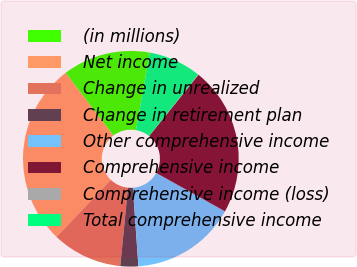Convert chart to OTSL. <chart><loc_0><loc_0><loc_500><loc_500><pie_chart><fcel>(in millions)<fcel>Net income<fcel>Change in unrealized<fcel>Change in retirement plan<fcel>Other comprehensive income<fcel>Comprehensive income<fcel>Comprehensive income (loss)<fcel>Total comprehensive income<nl><fcel>13.15%<fcel>27.56%<fcel>10.54%<fcel>2.68%<fcel>15.77%<fcel>22.32%<fcel>0.06%<fcel>7.92%<nl></chart> 